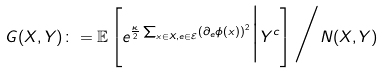<formula> <loc_0><loc_0><loc_500><loc_500>G ( X , Y ) \colon = \mathbb { E } \left [ e ^ { \frac { \kappa } { 2 } \sum _ { x \in X , e \in \mathcal { E } } ( \partial _ { e } \phi ( x ) ) ^ { 2 } } \Big | Y ^ { c } \right ] \Big / N ( X , Y )</formula> 